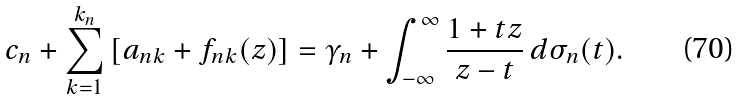Convert formula to latex. <formula><loc_0><loc_0><loc_500><loc_500>c _ { n } + \sum _ { k = 1 } ^ { k _ { n } } \left [ a _ { n k } + f _ { n k } ( z ) \right ] = \gamma _ { n } + \int _ { - \infty } ^ { \infty } \frac { 1 + t z } { z - t } \, d \sigma _ { n } ( t ) .</formula> 